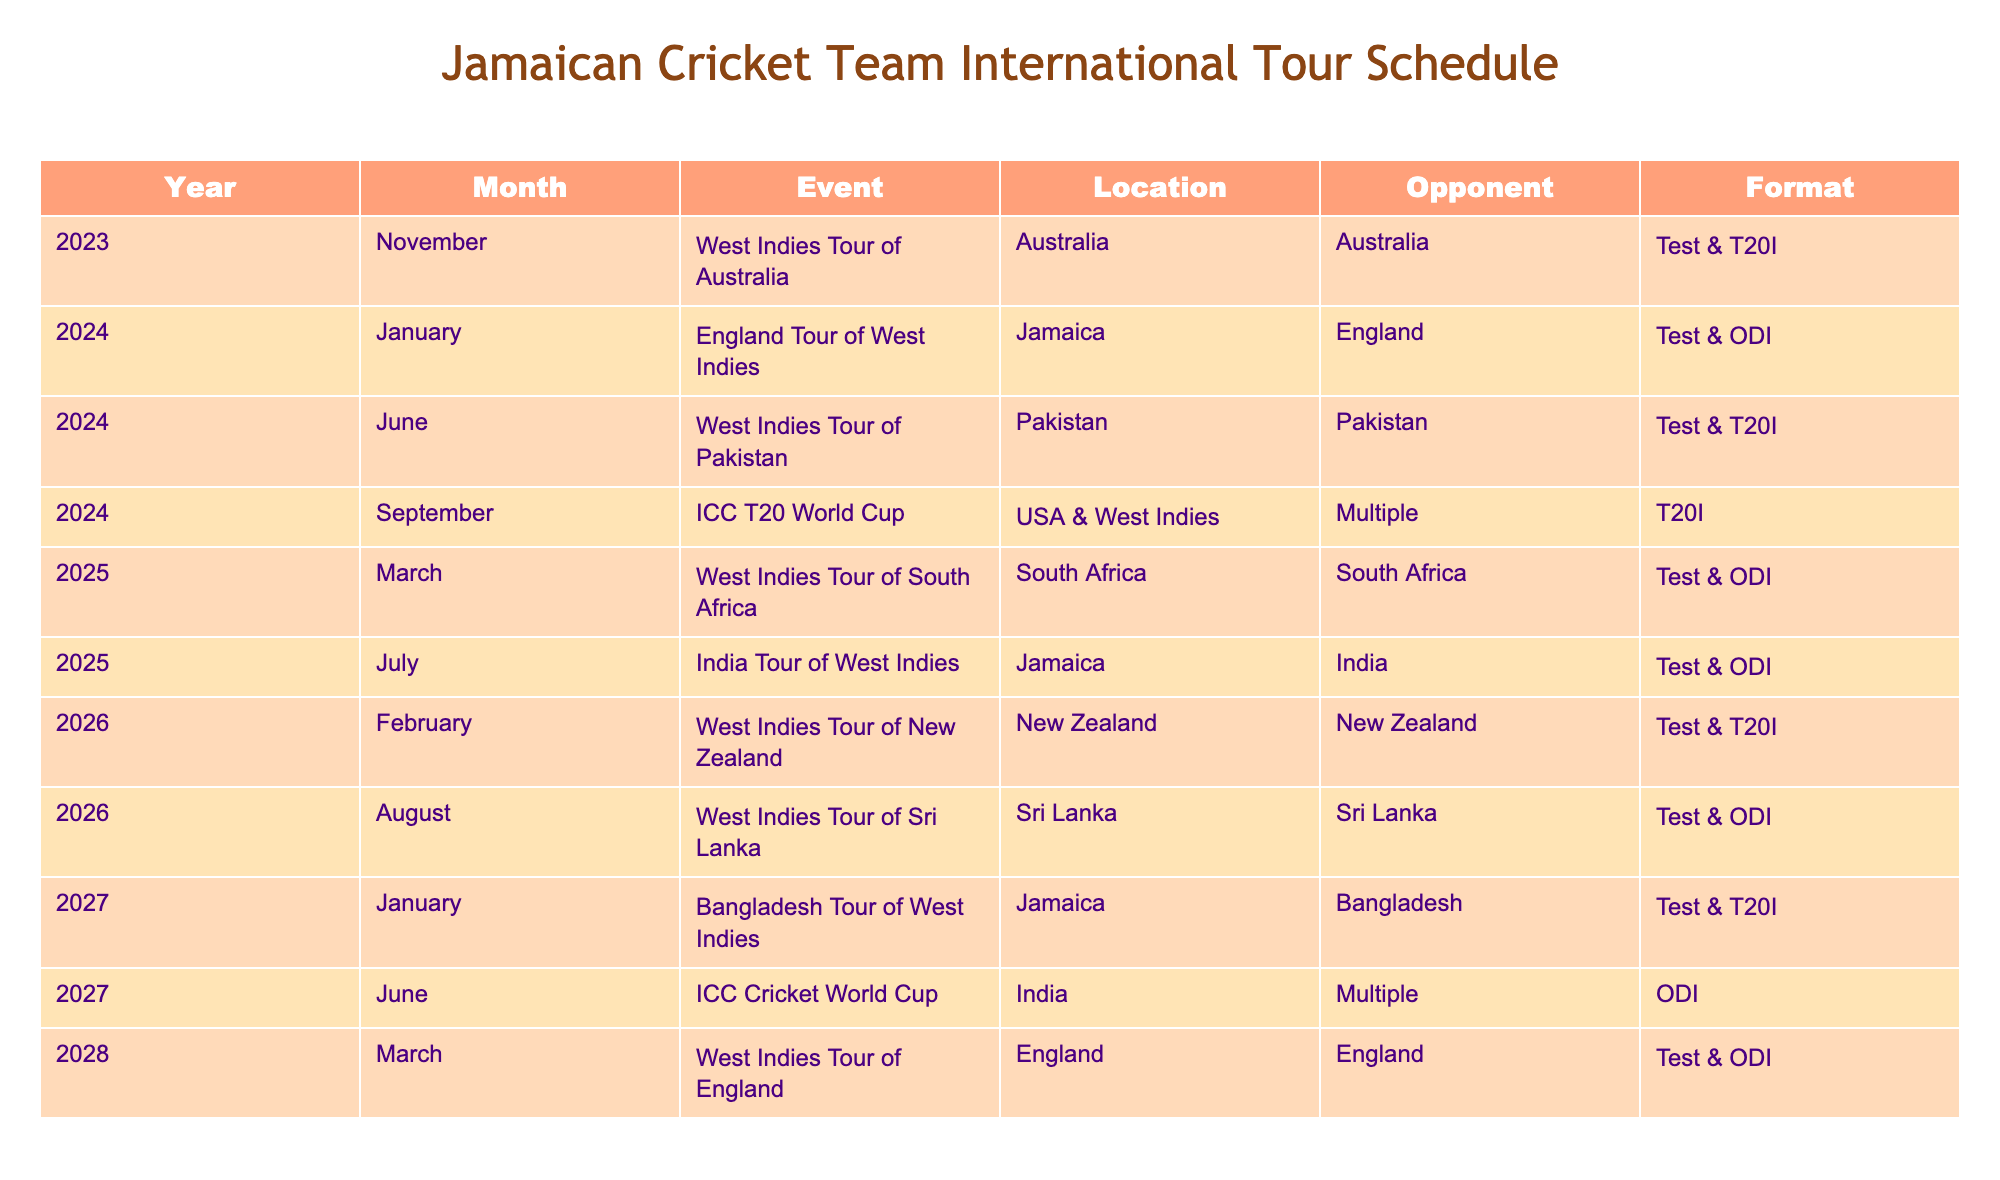What is the location of the ICC T20 World Cup in 2024? The ICC T20 World Cup in 2024 is scheduled to take place in the USA and West Indies, as specified in the Location column for that event.
Answer: USA & West Indies How many matches will the West Indies play in 2025? In 2025, the West Indies will play two tours: one against South Africa (Test & ODI) and one against India (Test & ODI). This totals four matches, considering they play two formats in each tour.
Answer: 4 Is there a Test match planned against England in 2028? Yes, according to the table, the West Indies will have a Test match against England in March 2028.
Answer: Yes What is the format of the West Indies Tour of Pakistan in June 2024? The West Indies Tour of Pakistan is set to be in Test and T20I formats as indicated under Format for that event.
Answer: Test & T20I How many tours are scheduled for the West Indies in 2026? The West Indies have two tours planned in 2026 – one to New Zealand and another to Sri Lanka, as per the Monthly data in that year. Hence, there are a total of two tours.
Answer: 2 Which tour will take place before the ICC Cricket World Cup in 2027? The Bangladesh Tour of West Indies will take place in January 2027, before the ICC Cricket World Cup scheduled for June 2027.
Answer: Bangladesh Tour of West Indies What is the total number of events scheduled in 2024? In 2024, there are four events listed: England Tour of West Indies, West Indies Tour of Pakistan, the ICC T20 World Cup, making the total number of events four.
Answer: 4 Which opponent will the West Indies face at home in July 2025? The West Indies will face India at home in July 2025, as listed in the table under the corresponding month and year.
Answer: India In which month will the first event of the timeline occur? The first event is the West Indies Tour of Australia occurring in November 2023, which is the first month listed in the timeline.
Answer: November 